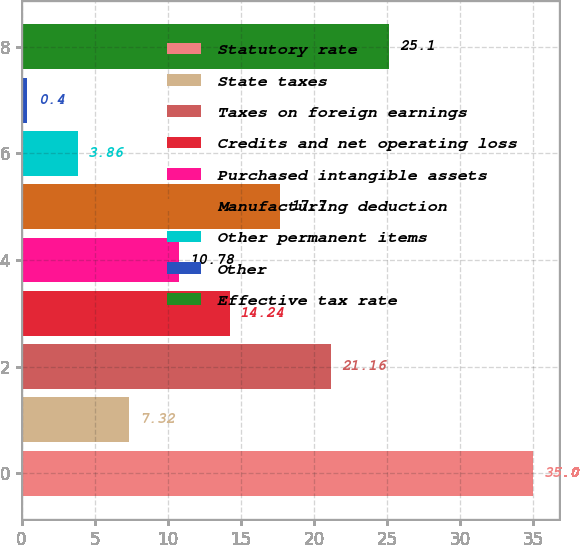Convert chart to OTSL. <chart><loc_0><loc_0><loc_500><loc_500><bar_chart><fcel>Statutory rate<fcel>State taxes<fcel>Taxes on foreign earnings<fcel>Credits and net operating loss<fcel>Purchased intangible assets<fcel>Manufacturing deduction<fcel>Other permanent items<fcel>Other<fcel>Effective tax rate<nl><fcel>35<fcel>7.32<fcel>21.16<fcel>14.24<fcel>10.78<fcel>17.7<fcel>3.86<fcel>0.4<fcel>25.1<nl></chart> 